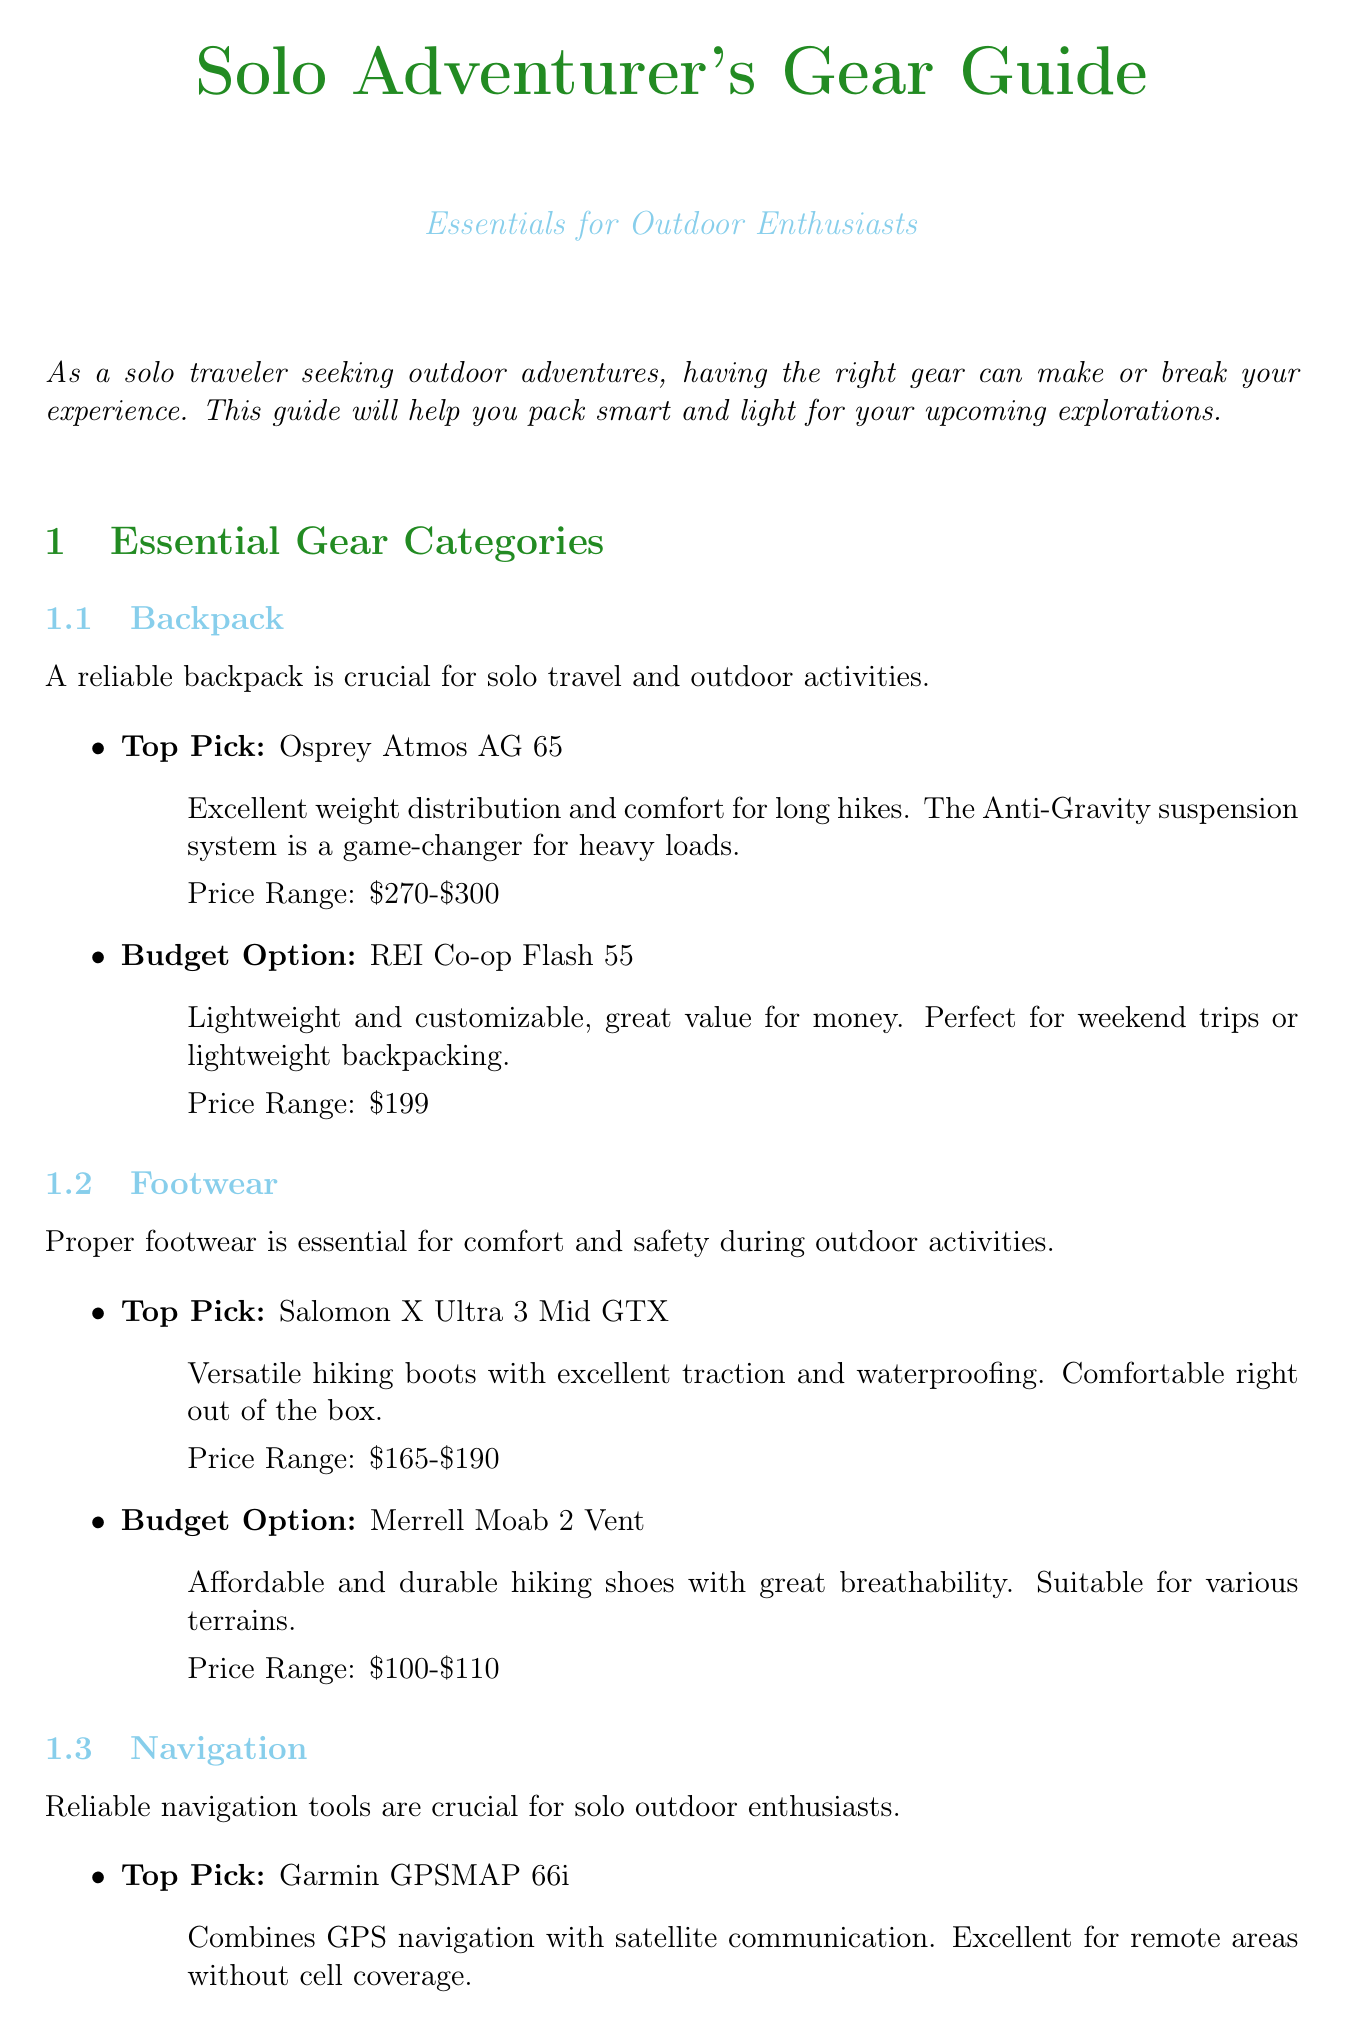What is the title of the newsletter? The title of the newsletter as stated at the top is "Solo Adventurer's Gear Guide: Essentials for Outdoor Enthusiasts."
Answer: Solo Adventurer's Gear Guide: Essentials for Outdoor Enthusiasts What is the price range for the Osprey Atmos AG 65? The price range for the Osprey Atmos AG 65 as mentioned in the product review section is between $270 and $300.
Answer: $270-$300 Which item is recommended for hydration? The document suggests bringing a water filtration system for safe drinking water, specifically mentioning the Sawyer Squeeze.
Answer: Sawyer Squeeze What is a recommended navigation tool for remote areas? The Garmin GPSMAP 66i is highlighted as a navigation tool that combines GPS navigation with satellite communication for remote areas.
Answer: Garmin GPSMAP 66i What is one multi-purpose use for the Leatherman Wave+ Multi-tool? One of the uses for the Leatherman Wave+ is for gear repairs as indicated in the multi-purpose gear recommendations section.
Answer: Gear repairs What is the budget option for footwear? The budget option for footwear listed in the document is the Merrell Moab 2 Vent.
Answer: Merrell Moab 2 Vent How many packing tips are provided? The document includes a total of five packing tips for solo outdoor enthusiasts.
Answer: Five What should you do before your adventure according to safety tips? The document suggests sharing your itinerary with a trusted friend or family member before embarking on your adventure.
Answer: Share your itinerary What is recommended for cooling clothing? The document recommends opting for quick-dry, moisture-wicking clothing to stay comfortable during outdoor activities.
Answer: Quick-dry, moisture-wicking clothing 